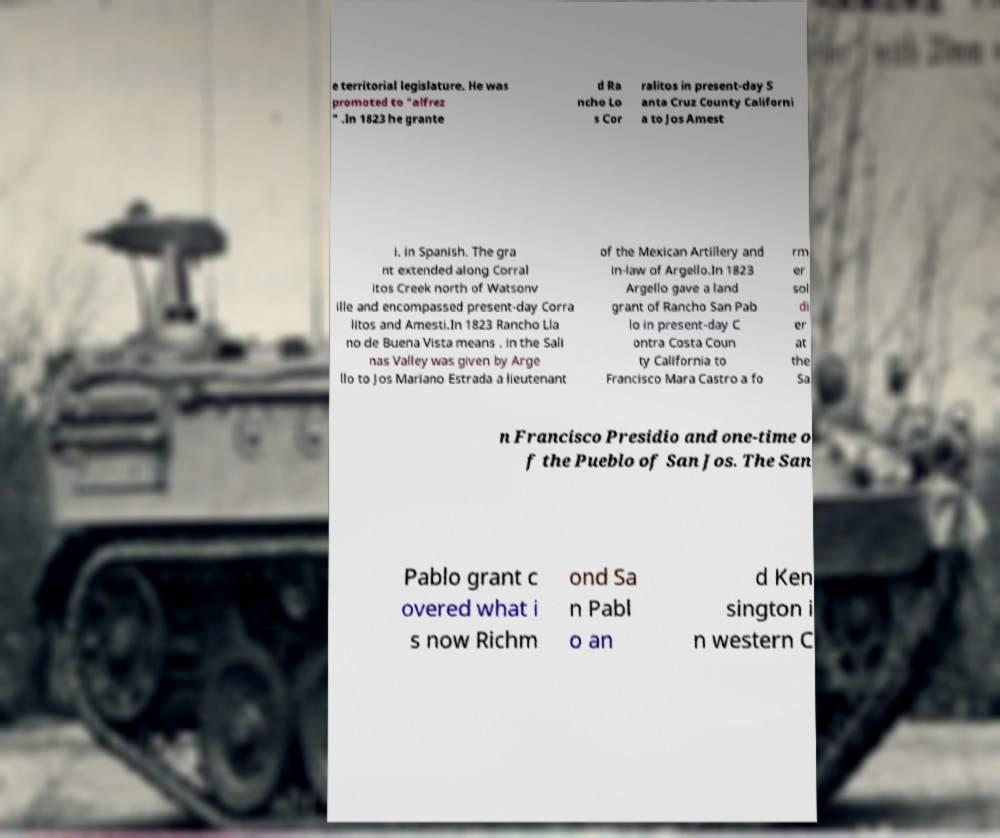What messages or text are displayed in this image? I need them in a readable, typed format. e territorial legislature. He was promoted to "alfrez " .In 1823 he grante d Ra ncho Lo s Cor ralitos in present-day S anta Cruz County Californi a to Jos Amest i. in Spanish. The gra nt extended along Corral itos Creek north of Watsonv ille and encompassed present-day Corra litos and Amesti.In 1823 Rancho Lla no de Buena Vista means . in the Sali nas Valley was given by Arge llo to Jos Mariano Estrada a lieutenant of the Mexican Artillery and in-law of Argello.In 1823 Argello gave a land grant of Rancho San Pab lo in present-day C ontra Costa Coun ty California to Francisco Mara Castro a fo rm er sol di er at the Sa n Francisco Presidio and one-time o f the Pueblo of San Jos. The San Pablo grant c overed what i s now Richm ond Sa n Pabl o an d Ken sington i n western C 